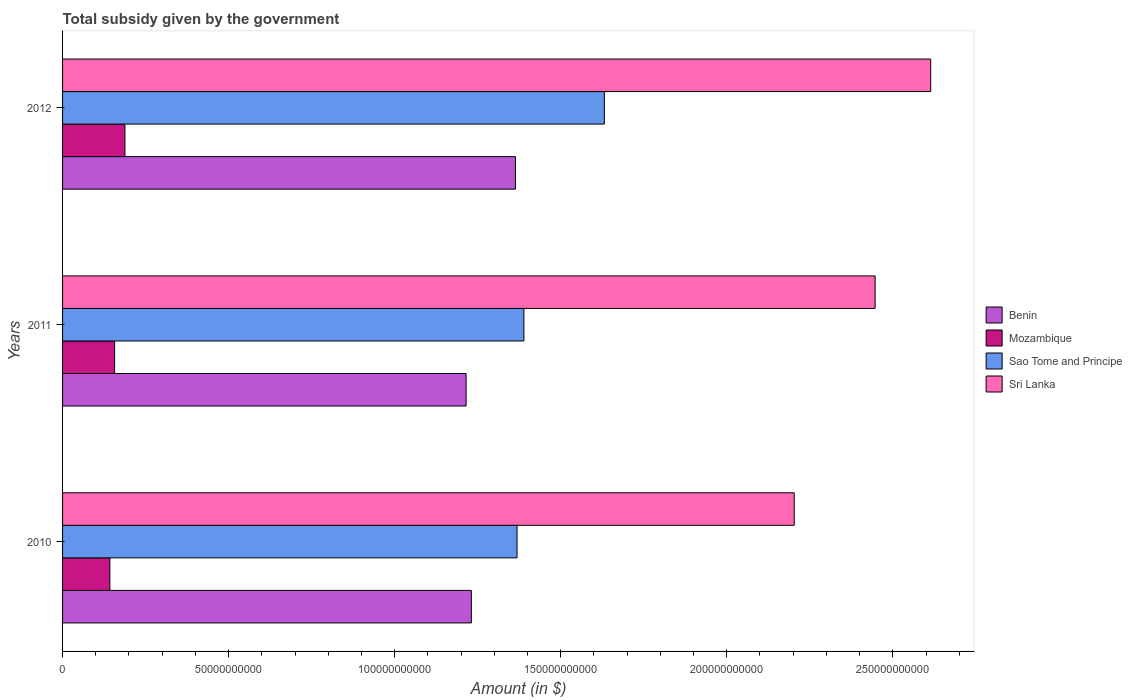How many groups of bars are there?
Provide a succinct answer. 3. Are the number of bars per tick equal to the number of legend labels?
Your answer should be very brief. Yes. What is the label of the 1st group of bars from the top?
Your answer should be compact. 2012. In how many cases, is the number of bars for a given year not equal to the number of legend labels?
Make the answer very short. 0. What is the total revenue collected by the government in Sao Tome and Principe in 2010?
Your answer should be very brief. 1.37e+11. Across all years, what is the maximum total revenue collected by the government in Mozambique?
Provide a short and direct response. 1.88e+1. Across all years, what is the minimum total revenue collected by the government in Sri Lanka?
Your answer should be very brief. 2.20e+11. In which year was the total revenue collected by the government in Benin maximum?
Offer a terse response. 2012. In which year was the total revenue collected by the government in Benin minimum?
Give a very brief answer. 2011. What is the total total revenue collected by the government in Sao Tome and Principe in the graph?
Offer a very short reply. 4.39e+11. What is the difference between the total revenue collected by the government in Benin in 2010 and that in 2011?
Offer a terse response. 1.58e+09. What is the difference between the total revenue collected by the government in Mozambique in 2010 and the total revenue collected by the government in Sao Tome and Principe in 2011?
Keep it short and to the point. -1.25e+11. What is the average total revenue collected by the government in Sri Lanka per year?
Your answer should be very brief. 2.42e+11. In the year 2010, what is the difference between the total revenue collected by the government in Sri Lanka and total revenue collected by the government in Sao Tome and Principe?
Offer a very short reply. 8.35e+1. What is the ratio of the total revenue collected by the government in Mozambique in 2010 to that in 2011?
Ensure brevity in your answer.  0.91. Is the difference between the total revenue collected by the government in Sri Lanka in 2010 and 2011 greater than the difference between the total revenue collected by the government in Sao Tome and Principe in 2010 and 2011?
Offer a very short reply. No. What is the difference between the highest and the second highest total revenue collected by the government in Sao Tome and Principe?
Make the answer very short. 2.42e+1. What is the difference between the highest and the lowest total revenue collected by the government in Sri Lanka?
Make the answer very short. 4.11e+1. Is it the case that in every year, the sum of the total revenue collected by the government in Sao Tome and Principe and total revenue collected by the government in Benin is greater than the sum of total revenue collected by the government in Mozambique and total revenue collected by the government in Sri Lanka?
Give a very brief answer. No. What does the 3rd bar from the top in 2010 represents?
Provide a succinct answer. Mozambique. What does the 4th bar from the bottom in 2010 represents?
Offer a very short reply. Sri Lanka. Is it the case that in every year, the sum of the total revenue collected by the government in Sao Tome and Principe and total revenue collected by the government in Sri Lanka is greater than the total revenue collected by the government in Mozambique?
Your response must be concise. Yes. How many bars are there?
Offer a very short reply. 12. Are the values on the major ticks of X-axis written in scientific E-notation?
Offer a terse response. No. Does the graph contain any zero values?
Make the answer very short. No. Does the graph contain grids?
Give a very brief answer. No. Where does the legend appear in the graph?
Offer a very short reply. Center right. How many legend labels are there?
Offer a very short reply. 4. How are the legend labels stacked?
Provide a short and direct response. Vertical. What is the title of the graph?
Provide a succinct answer. Total subsidy given by the government. What is the label or title of the X-axis?
Offer a very short reply. Amount (in $). What is the label or title of the Y-axis?
Your answer should be very brief. Years. What is the Amount (in $) in Benin in 2010?
Offer a very short reply. 1.23e+11. What is the Amount (in $) in Mozambique in 2010?
Your answer should be compact. 1.42e+1. What is the Amount (in $) of Sao Tome and Principe in 2010?
Make the answer very short. 1.37e+11. What is the Amount (in $) of Sri Lanka in 2010?
Make the answer very short. 2.20e+11. What is the Amount (in $) of Benin in 2011?
Your answer should be very brief. 1.22e+11. What is the Amount (in $) of Mozambique in 2011?
Offer a very short reply. 1.57e+1. What is the Amount (in $) in Sao Tome and Principe in 2011?
Offer a terse response. 1.39e+11. What is the Amount (in $) in Sri Lanka in 2011?
Provide a succinct answer. 2.45e+11. What is the Amount (in $) of Benin in 2012?
Ensure brevity in your answer.  1.36e+11. What is the Amount (in $) of Mozambique in 2012?
Your response must be concise. 1.88e+1. What is the Amount (in $) in Sao Tome and Principe in 2012?
Give a very brief answer. 1.63e+11. What is the Amount (in $) of Sri Lanka in 2012?
Offer a very short reply. 2.61e+11. Across all years, what is the maximum Amount (in $) of Benin?
Give a very brief answer. 1.36e+11. Across all years, what is the maximum Amount (in $) of Mozambique?
Give a very brief answer. 1.88e+1. Across all years, what is the maximum Amount (in $) of Sao Tome and Principe?
Your response must be concise. 1.63e+11. Across all years, what is the maximum Amount (in $) of Sri Lanka?
Give a very brief answer. 2.61e+11. Across all years, what is the minimum Amount (in $) in Benin?
Keep it short and to the point. 1.22e+11. Across all years, what is the minimum Amount (in $) in Mozambique?
Provide a succinct answer. 1.42e+1. Across all years, what is the minimum Amount (in $) in Sao Tome and Principe?
Provide a short and direct response. 1.37e+11. Across all years, what is the minimum Amount (in $) in Sri Lanka?
Make the answer very short. 2.20e+11. What is the total Amount (in $) of Benin in the graph?
Offer a very short reply. 3.81e+11. What is the total Amount (in $) in Mozambique in the graph?
Your response must be concise. 4.87e+1. What is the total Amount (in $) in Sao Tome and Principe in the graph?
Provide a succinct answer. 4.39e+11. What is the total Amount (in $) in Sri Lanka in the graph?
Ensure brevity in your answer.  7.26e+11. What is the difference between the Amount (in $) in Benin in 2010 and that in 2011?
Offer a terse response. 1.58e+09. What is the difference between the Amount (in $) of Mozambique in 2010 and that in 2011?
Provide a succinct answer. -1.43e+09. What is the difference between the Amount (in $) of Sao Tome and Principe in 2010 and that in 2011?
Offer a terse response. -2.07e+09. What is the difference between the Amount (in $) of Sri Lanka in 2010 and that in 2011?
Your response must be concise. -2.44e+1. What is the difference between the Amount (in $) of Benin in 2010 and that in 2012?
Ensure brevity in your answer.  -1.33e+1. What is the difference between the Amount (in $) in Mozambique in 2010 and that in 2012?
Offer a terse response. -4.54e+09. What is the difference between the Amount (in $) of Sao Tome and Principe in 2010 and that in 2012?
Ensure brevity in your answer.  -2.63e+1. What is the difference between the Amount (in $) in Sri Lanka in 2010 and that in 2012?
Provide a succinct answer. -4.11e+1. What is the difference between the Amount (in $) of Benin in 2011 and that in 2012?
Ensure brevity in your answer.  -1.49e+1. What is the difference between the Amount (in $) of Mozambique in 2011 and that in 2012?
Give a very brief answer. -3.11e+09. What is the difference between the Amount (in $) in Sao Tome and Principe in 2011 and that in 2012?
Provide a short and direct response. -2.42e+1. What is the difference between the Amount (in $) of Sri Lanka in 2011 and that in 2012?
Keep it short and to the point. -1.67e+1. What is the difference between the Amount (in $) in Benin in 2010 and the Amount (in $) in Mozambique in 2011?
Offer a terse response. 1.07e+11. What is the difference between the Amount (in $) in Benin in 2010 and the Amount (in $) in Sao Tome and Principe in 2011?
Give a very brief answer. -1.58e+1. What is the difference between the Amount (in $) of Benin in 2010 and the Amount (in $) of Sri Lanka in 2011?
Provide a short and direct response. -1.22e+11. What is the difference between the Amount (in $) in Mozambique in 2010 and the Amount (in $) in Sao Tome and Principe in 2011?
Offer a terse response. -1.25e+11. What is the difference between the Amount (in $) in Mozambique in 2010 and the Amount (in $) in Sri Lanka in 2011?
Offer a very short reply. -2.30e+11. What is the difference between the Amount (in $) of Sao Tome and Principe in 2010 and the Amount (in $) of Sri Lanka in 2011?
Give a very brief answer. -1.08e+11. What is the difference between the Amount (in $) of Benin in 2010 and the Amount (in $) of Mozambique in 2012?
Give a very brief answer. 1.04e+11. What is the difference between the Amount (in $) of Benin in 2010 and the Amount (in $) of Sao Tome and Principe in 2012?
Offer a terse response. -4.01e+1. What is the difference between the Amount (in $) in Benin in 2010 and the Amount (in $) in Sri Lanka in 2012?
Make the answer very short. -1.38e+11. What is the difference between the Amount (in $) in Mozambique in 2010 and the Amount (in $) in Sao Tome and Principe in 2012?
Keep it short and to the point. -1.49e+11. What is the difference between the Amount (in $) of Mozambique in 2010 and the Amount (in $) of Sri Lanka in 2012?
Provide a short and direct response. -2.47e+11. What is the difference between the Amount (in $) in Sao Tome and Principe in 2010 and the Amount (in $) in Sri Lanka in 2012?
Give a very brief answer. -1.25e+11. What is the difference between the Amount (in $) in Benin in 2011 and the Amount (in $) in Mozambique in 2012?
Offer a very short reply. 1.03e+11. What is the difference between the Amount (in $) in Benin in 2011 and the Amount (in $) in Sao Tome and Principe in 2012?
Your answer should be very brief. -4.16e+1. What is the difference between the Amount (in $) in Benin in 2011 and the Amount (in $) in Sri Lanka in 2012?
Your answer should be very brief. -1.40e+11. What is the difference between the Amount (in $) of Mozambique in 2011 and the Amount (in $) of Sao Tome and Principe in 2012?
Offer a terse response. -1.47e+11. What is the difference between the Amount (in $) of Mozambique in 2011 and the Amount (in $) of Sri Lanka in 2012?
Ensure brevity in your answer.  -2.46e+11. What is the difference between the Amount (in $) in Sao Tome and Principe in 2011 and the Amount (in $) in Sri Lanka in 2012?
Offer a terse response. -1.22e+11. What is the average Amount (in $) in Benin per year?
Make the answer very short. 1.27e+11. What is the average Amount (in $) in Mozambique per year?
Your answer should be compact. 1.62e+1. What is the average Amount (in $) in Sao Tome and Principe per year?
Make the answer very short. 1.46e+11. What is the average Amount (in $) in Sri Lanka per year?
Provide a succinct answer. 2.42e+11. In the year 2010, what is the difference between the Amount (in $) of Benin and Amount (in $) of Mozambique?
Ensure brevity in your answer.  1.09e+11. In the year 2010, what is the difference between the Amount (in $) in Benin and Amount (in $) in Sao Tome and Principe?
Your answer should be compact. -1.38e+1. In the year 2010, what is the difference between the Amount (in $) of Benin and Amount (in $) of Sri Lanka?
Keep it short and to the point. -9.72e+1. In the year 2010, what is the difference between the Amount (in $) of Mozambique and Amount (in $) of Sao Tome and Principe?
Ensure brevity in your answer.  -1.23e+11. In the year 2010, what is the difference between the Amount (in $) of Mozambique and Amount (in $) of Sri Lanka?
Make the answer very short. -2.06e+11. In the year 2010, what is the difference between the Amount (in $) in Sao Tome and Principe and Amount (in $) in Sri Lanka?
Your answer should be very brief. -8.35e+1. In the year 2011, what is the difference between the Amount (in $) of Benin and Amount (in $) of Mozambique?
Offer a terse response. 1.06e+11. In the year 2011, what is the difference between the Amount (in $) of Benin and Amount (in $) of Sao Tome and Principe?
Offer a very short reply. -1.74e+1. In the year 2011, what is the difference between the Amount (in $) of Benin and Amount (in $) of Sri Lanka?
Provide a succinct answer. -1.23e+11. In the year 2011, what is the difference between the Amount (in $) in Mozambique and Amount (in $) in Sao Tome and Principe?
Your answer should be compact. -1.23e+11. In the year 2011, what is the difference between the Amount (in $) in Mozambique and Amount (in $) in Sri Lanka?
Ensure brevity in your answer.  -2.29e+11. In the year 2011, what is the difference between the Amount (in $) in Sao Tome and Principe and Amount (in $) in Sri Lanka?
Offer a terse response. -1.06e+11. In the year 2012, what is the difference between the Amount (in $) in Benin and Amount (in $) in Mozambique?
Provide a short and direct response. 1.18e+11. In the year 2012, what is the difference between the Amount (in $) of Benin and Amount (in $) of Sao Tome and Principe?
Your response must be concise. -2.68e+1. In the year 2012, what is the difference between the Amount (in $) in Benin and Amount (in $) in Sri Lanka?
Your answer should be very brief. -1.25e+11. In the year 2012, what is the difference between the Amount (in $) in Mozambique and Amount (in $) in Sao Tome and Principe?
Keep it short and to the point. -1.44e+11. In the year 2012, what is the difference between the Amount (in $) in Mozambique and Amount (in $) in Sri Lanka?
Your response must be concise. -2.43e+11. In the year 2012, what is the difference between the Amount (in $) in Sao Tome and Principe and Amount (in $) in Sri Lanka?
Keep it short and to the point. -9.83e+1. What is the ratio of the Amount (in $) in Benin in 2010 to that in 2011?
Your response must be concise. 1.01. What is the ratio of the Amount (in $) of Mozambique in 2010 to that in 2011?
Your answer should be compact. 0.91. What is the ratio of the Amount (in $) in Sao Tome and Principe in 2010 to that in 2011?
Make the answer very short. 0.99. What is the ratio of the Amount (in $) in Sri Lanka in 2010 to that in 2011?
Keep it short and to the point. 0.9. What is the ratio of the Amount (in $) of Benin in 2010 to that in 2012?
Keep it short and to the point. 0.9. What is the ratio of the Amount (in $) of Mozambique in 2010 to that in 2012?
Provide a succinct answer. 0.76. What is the ratio of the Amount (in $) in Sao Tome and Principe in 2010 to that in 2012?
Make the answer very short. 0.84. What is the ratio of the Amount (in $) in Sri Lanka in 2010 to that in 2012?
Keep it short and to the point. 0.84. What is the ratio of the Amount (in $) in Benin in 2011 to that in 2012?
Your answer should be very brief. 0.89. What is the ratio of the Amount (in $) of Mozambique in 2011 to that in 2012?
Offer a terse response. 0.83. What is the ratio of the Amount (in $) in Sao Tome and Principe in 2011 to that in 2012?
Your answer should be compact. 0.85. What is the ratio of the Amount (in $) of Sri Lanka in 2011 to that in 2012?
Provide a short and direct response. 0.94. What is the difference between the highest and the second highest Amount (in $) in Benin?
Your answer should be very brief. 1.33e+1. What is the difference between the highest and the second highest Amount (in $) of Mozambique?
Offer a very short reply. 3.11e+09. What is the difference between the highest and the second highest Amount (in $) in Sao Tome and Principe?
Ensure brevity in your answer.  2.42e+1. What is the difference between the highest and the second highest Amount (in $) of Sri Lanka?
Keep it short and to the point. 1.67e+1. What is the difference between the highest and the lowest Amount (in $) in Benin?
Ensure brevity in your answer.  1.49e+1. What is the difference between the highest and the lowest Amount (in $) of Mozambique?
Offer a very short reply. 4.54e+09. What is the difference between the highest and the lowest Amount (in $) in Sao Tome and Principe?
Offer a very short reply. 2.63e+1. What is the difference between the highest and the lowest Amount (in $) of Sri Lanka?
Provide a short and direct response. 4.11e+1. 